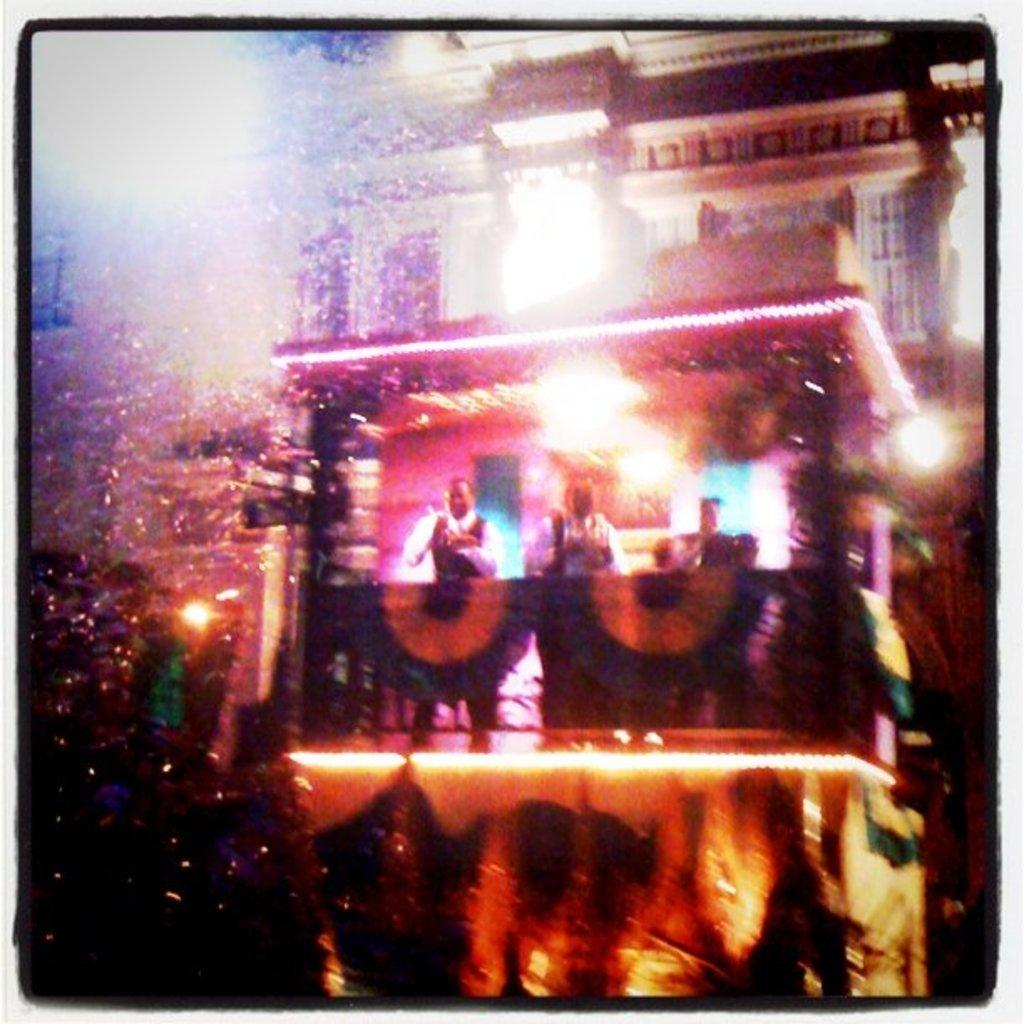What is the main subject in the center of the image? There is a building in the center of the image. How many people can be seen in the image? There are three persons standing in the image. What can be seen illuminating the scene in the image? There are lights visible in the image. Can you describe any other objects present in the image? There are other objects present in the image, but their specific details are not mentioned in the provided facts. What type of hook can be seen attached to the front of the trucks in the image? There are no trucks present in the image, so there is no hook to be seen. 